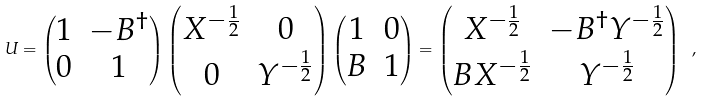Convert formula to latex. <formula><loc_0><loc_0><loc_500><loc_500>U = \begin{pmatrix} 1 & - B ^ { \dag } \\ 0 & 1 \end{pmatrix} \begin{pmatrix} X ^ { - \frac { 1 } { 2 } } & 0 \\ 0 & Y ^ { - \frac { 1 } { 2 } } \end{pmatrix} \begin{pmatrix} 1 & 0 \\ B & 1 \end{pmatrix} = \begin{pmatrix} X ^ { - \frac { 1 } { 2 } } & - B ^ { \dag } Y ^ { - \frac { 1 } { 2 } } \\ B X ^ { - \frac { 1 } { 2 } } & Y ^ { - \frac { 1 } { 2 } } \end{pmatrix} \ ,</formula> 